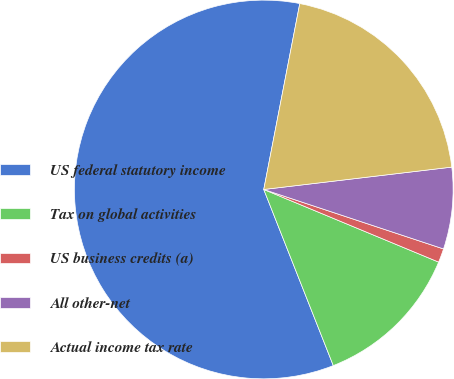Convert chart. <chart><loc_0><loc_0><loc_500><loc_500><pie_chart><fcel>US federal statutory income<fcel>Tax on global activities<fcel>US business credits (a)<fcel>All other-net<fcel>Actual income tax rate<nl><fcel>59.03%<fcel>12.75%<fcel>1.18%<fcel>6.97%<fcel>20.07%<nl></chart> 